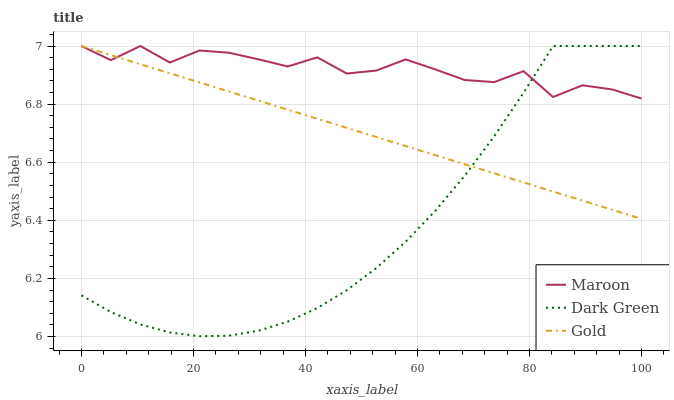Does Dark Green have the minimum area under the curve?
Answer yes or no. Yes. Does Maroon have the maximum area under the curve?
Answer yes or no. Yes. Does Maroon have the minimum area under the curve?
Answer yes or no. No. Does Dark Green have the maximum area under the curve?
Answer yes or no. No. Is Gold the smoothest?
Answer yes or no. Yes. Is Maroon the roughest?
Answer yes or no. Yes. Is Dark Green the smoothest?
Answer yes or no. No. Is Dark Green the roughest?
Answer yes or no. No. Does Maroon have the lowest value?
Answer yes or no. No. Does Dark Green have the highest value?
Answer yes or no. Yes. Does Maroon intersect Dark Green?
Answer yes or no. Yes. Is Maroon less than Dark Green?
Answer yes or no. No. Is Maroon greater than Dark Green?
Answer yes or no. No. 